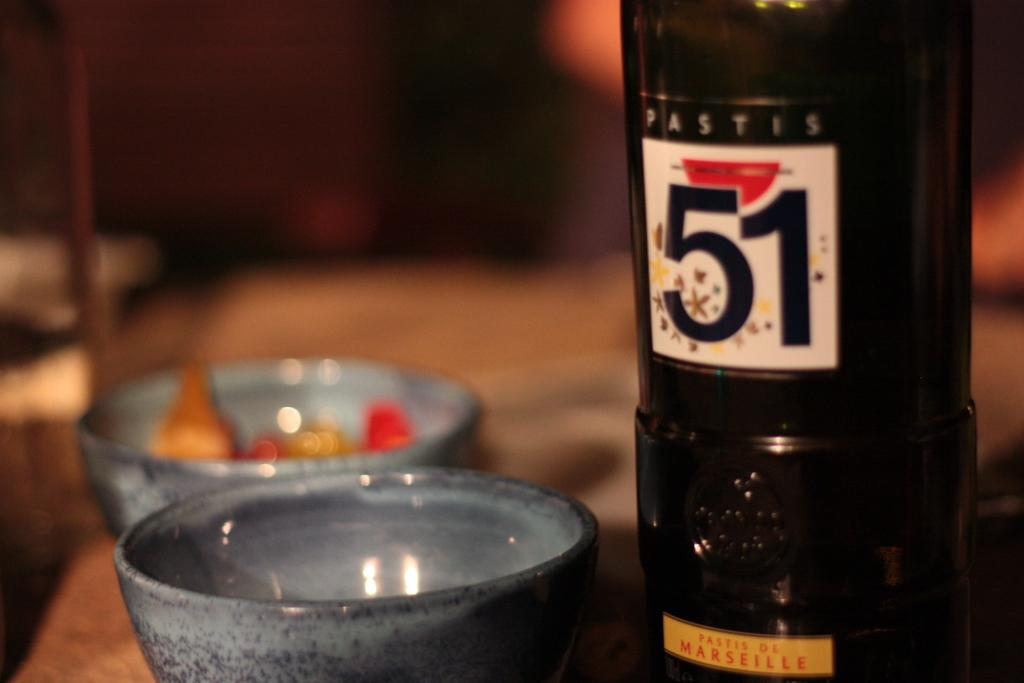<image>
Present a compact description of the photo's key features. A bottle of Pastis is on a table near some bowls. 